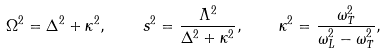<formula> <loc_0><loc_0><loc_500><loc_500>\Omega ^ { 2 } = \Delta ^ { 2 } + \kappa ^ { 2 } , \quad s ^ { 2 } = \frac { \Lambda ^ { 2 } } { \Delta ^ { 2 } + \kappa ^ { 2 } } , \quad \kappa ^ { 2 } = \frac { \omega _ { T } ^ { 2 } } { \omega _ { L } ^ { 2 } - \omega _ { T } ^ { 2 } } ,</formula> 